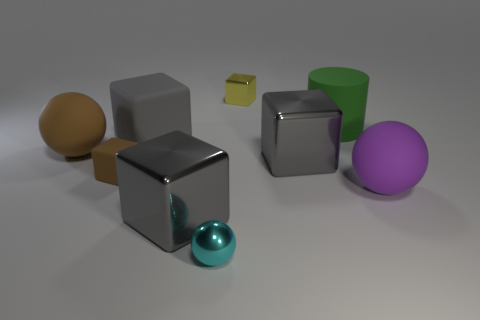Subtract all yellow spheres. How many gray blocks are left? 3 Subtract all large gray blocks. How many blocks are left? 2 Subtract all yellow cubes. How many cubes are left? 4 Subtract all cyan cubes. Subtract all green spheres. How many cubes are left? 5 Add 1 large cyan rubber blocks. How many objects exist? 10 Subtract 0 yellow spheres. How many objects are left? 9 Subtract all blocks. How many objects are left? 4 Subtract all large rubber blocks. Subtract all small rubber things. How many objects are left? 7 Add 2 spheres. How many spheres are left? 5 Add 6 big gray metallic blocks. How many big gray metallic blocks exist? 8 